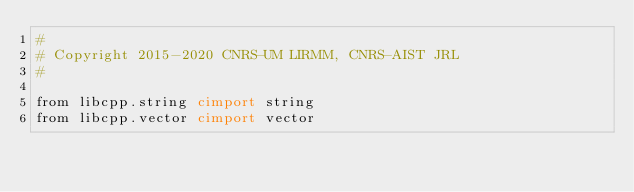Convert code to text. <code><loc_0><loc_0><loc_500><loc_500><_Cython_>#
# Copyright 2015-2020 CNRS-UM LIRMM, CNRS-AIST JRL
#

from libcpp.string cimport string
from libcpp.vector cimport vector</code> 